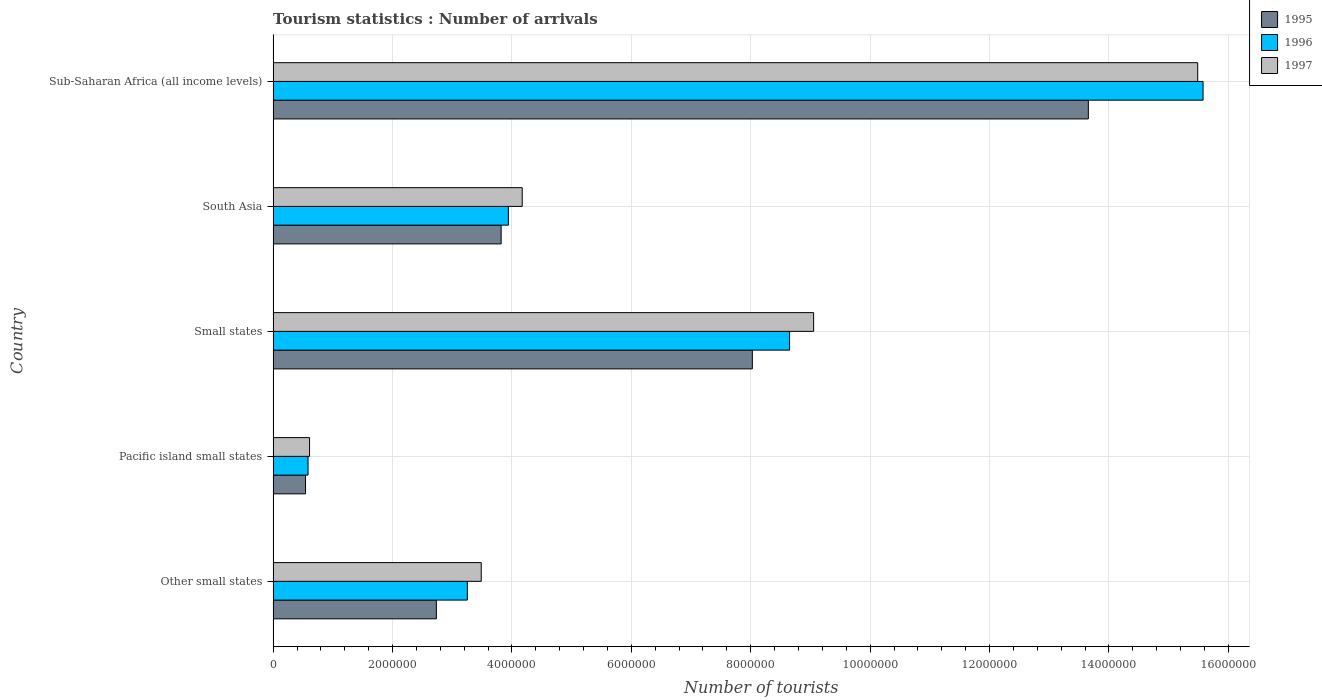How many different coloured bars are there?
Keep it short and to the point. 3. Are the number of bars per tick equal to the number of legend labels?
Your response must be concise. Yes. Are the number of bars on each tick of the Y-axis equal?
Give a very brief answer. Yes. What is the label of the 5th group of bars from the top?
Your response must be concise. Other small states. In how many cases, is the number of bars for a given country not equal to the number of legend labels?
Offer a very short reply. 0. What is the number of tourist arrivals in 1996 in South Asia?
Your response must be concise. 3.94e+06. Across all countries, what is the maximum number of tourist arrivals in 1997?
Provide a succinct answer. 1.55e+07. Across all countries, what is the minimum number of tourist arrivals in 1995?
Offer a very short reply. 5.43e+05. In which country was the number of tourist arrivals in 1997 maximum?
Your answer should be very brief. Sub-Saharan Africa (all income levels). In which country was the number of tourist arrivals in 1997 minimum?
Keep it short and to the point. Pacific island small states. What is the total number of tourist arrivals in 1997 in the graph?
Offer a very short reply. 3.28e+07. What is the difference between the number of tourist arrivals in 1995 in South Asia and that in Sub-Saharan Africa (all income levels)?
Make the answer very short. -9.84e+06. What is the difference between the number of tourist arrivals in 1995 in South Asia and the number of tourist arrivals in 1997 in Other small states?
Your answer should be very brief. 3.34e+05. What is the average number of tourist arrivals in 1997 per country?
Give a very brief answer. 6.56e+06. What is the difference between the number of tourist arrivals in 1997 and number of tourist arrivals in 1995 in Sub-Saharan Africa (all income levels)?
Your answer should be compact. 1.83e+06. In how many countries, is the number of tourist arrivals in 1997 greater than 10400000 ?
Make the answer very short. 1. What is the ratio of the number of tourist arrivals in 1997 in Other small states to that in South Asia?
Make the answer very short. 0.84. What is the difference between the highest and the second highest number of tourist arrivals in 1995?
Keep it short and to the point. 5.63e+06. What is the difference between the highest and the lowest number of tourist arrivals in 1996?
Give a very brief answer. 1.50e+07. In how many countries, is the number of tourist arrivals in 1996 greater than the average number of tourist arrivals in 1996 taken over all countries?
Make the answer very short. 2. Is the sum of the number of tourist arrivals in 1997 in Other small states and South Asia greater than the maximum number of tourist arrivals in 1996 across all countries?
Offer a very short reply. No. What does the 3rd bar from the bottom in Small states represents?
Ensure brevity in your answer.  1997. Are all the bars in the graph horizontal?
Make the answer very short. Yes. Does the graph contain grids?
Your answer should be very brief. Yes. Where does the legend appear in the graph?
Offer a very short reply. Top right. How many legend labels are there?
Keep it short and to the point. 3. What is the title of the graph?
Provide a short and direct response. Tourism statistics : Number of arrivals. What is the label or title of the X-axis?
Provide a succinct answer. Number of tourists. What is the label or title of the Y-axis?
Make the answer very short. Country. What is the Number of tourists of 1995 in Other small states?
Keep it short and to the point. 2.73e+06. What is the Number of tourists in 1996 in Other small states?
Provide a short and direct response. 3.25e+06. What is the Number of tourists in 1997 in Other small states?
Offer a terse response. 3.49e+06. What is the Number of tourists of 1995 in Pacific island small states?
Your response must be concise. 5.43e+05. What is the Number of tourists of 1996 in Pacific island small states?
Make the answer very short. 5.85e+05. What is the Number of tourists of 1997 in Pacific island small states?
Offer a very short reply. 6.10e+05. What is the Number of tourists in 1995 in Small states?
Provide a short and direct response. 8.03e+06. What is the Number of tourists in 1996 in Small states?
Offer a terse response. 8.65e+06. What is the Number of tourists of 1997 in Small states?
Your answer should be compact. 9.05e+06. What is the Number of tourists of 1995 in South Asia?
Provide a succinct answer. 3.82e+06. What is the Number of tourists of 1996 in South Asia?
Your response must be concise. 3.94e+06. What is the Number of tourists in 1997 in South Asia?
Provide a succinct answer. 4.17e+06. What is the Number of tourists in 1995 in Sub-Saharan Africa (all income levels)?
Offer a terse response. 1.37e+07. What is the Number of tourists in 1996 in Sub-Saharan Africa (all income levels)?
Ensure brevity in your answer.  1.56e+07. What is the Number of tourists in 1997 in Sub-Saharan Africa (all income levels)?
Make the answer very short. 1.55e+07. Across all countries, what is the maximum Number of tourists of 1995?
Your response must be concise. 1.37e+07. Across all countries, what is the maximum Number of tourists in 1996?
Your answer should be very brief. 1.56e+07. Across all countries, what is the maximum Number of tourists of 1997?
Your answer should be compact. 1.55e+07. Across all countries, what is the minimum Number of tourists in 1995?
Provide a short and direct response. 5.43e+05. Across all countries, what is the minimum Number of tourists in 1996?
Provide a short and direct response. 5.85e+05. Across all countries, what is the minimum Number of tourists of 1997?
Give a very brief answer. 6.10e+05. What is the total Number of tourists of 1995 in the graph?
Provide a short and direct response. 2.88e+07. What is the total Number of tourists in 1996 in the graph?
Your answer should be very brief. 3.20e+07. What is the total Number of tourists in 1997 in the graph?
Make the answer very short. 3.28e+07. What is the difference between the Number of tourists of 1995 in Other small states and that in Pacific island small states?
Ensure brevity in your answer.  2.19e+06. What is the difference between the Number of tourists of 1996 in Other small states and that in Pacific island small states?
Your answer should be very brief. 2.67e+06. What is the difference between the Number of tourists of 1997 in Other small states and that in Pacific island small states?
Make the answer very short. 2.88e+06. What is the difference between the Number of tourists of 1995 in Other small states and that in Small states?
Ensure brevity in your answer.  -5.29e+06. What is the difference between the Number of tourists of 1996 in Other small states and that in Small states?
Offer a terse response. -5.40e+06. What is the difference between the Number of tourists in 1997 in Other small states and that in Small states?
Provide a succinct answer. -5.57e+06. What is the difference between the Number of tourists of 1995 in Other small states and that in South Asia?
Offer a very short reply. -1.08e+06. What is the difference between the Number of tourists of 1996 in Other small states and that in South Asia?
Give a very brief answer. -6.87e+05. What is the difference between the Number of tourists in 1997 in Other small states and that in South Asia?
Make the answer very short. -6.87e+05. What is the difference between the Number of tourists of 1995 in Other small states and that in Sub-Saharan Africa (all income levels)?
Your answer should be very brief. -1.09e+07. What is the difference between the Number of tourists of 1996 in Other small states and that in Sub-Saharan Africa (all income levels)?
Ensure brevity in your answer.  -1.23e+07. What is the difference between the Number of tourists of 1997 in Other small states and that in Sub-Saharan Africa (all income levels)?
Provide a succinct answer. -1.20e+07. What is the difference between the Number of tourists of 1995 in Pacific island small states and that in Small states?
Offer a very short reply. -7.48e+06. What is the difference between the Number of tourists in 1996 in Pacific island small states and that in Small states?
Keep it short and to the point. -8.07e+06. What is the difference between the Number of tourists of 1997 in Pacific island small states and that in Small states?
Offer a terse response. -8.44e+06. What is the difference between the Number of tourists in 1995 in Pacific island small states and that in South Asia?
Your answer should be very brief. -3.28e+06. What is the difference between the Number of tourists in 1996 in Pacific island small states and that in South Asia?
Offer a very short reply. -3.36e+06. What is the difference between the Number of tourists in 1997 in Pacific island small states and that in South Asia?
Your answer should be compact. -3.56e+06. What is the difference between the Number of tourists in 1995 in Pacific island small states and that in Sub-Saharan Africa (all income levels)?
Your answer should be compact. -1.31e+07. What is the difference between the Number of tourists of 1996 in Pacific island small states and that in Sub-Saharan Africa (all income levels)?
Offer a very short reply. -1.50e+07. What is the difference between the Number of tourists of 1997 in Pacific island small states and that in Sub-Saharan Africa (all income levels)?
Give a very brief answer. -1.49e+07. What is the difference between the Number of tourists of 1995 in Small states and that in South Asia?
Offer a very short reply. 4.21e+06. What is the difference between the Number of tourists of 1996 in Small states and that in South Asia?
Offer a very short reply. 4.71e+06. What is the difference between the Number of tourists in 1997 in Small states and that in South Asia?
Offer a very short reply. 4.88e+06. What is the difference between the Number of tourists of 1995 in Small states and that in Sub-Saharan Africa (all income levels)?
Provide a succinct answer. -5.63e+06. What is the difference between the Number of tourists in 1996 in Small states and that in Sub-Saharan Africa (all income levels)?
Your answer should be compact. -6.93e+06. What is the difference between the Number of tourists of 1997 in Small states and that in Sub-Saharan Africa (all income levels)?
Your answer should be very brief. -6.43e+06. What is the difference between the Number of tourists in 1995 in South Asia and that in Sub-Saharan Africa (all income levels)?
Keep it short and to the point. -9.84e+06. What is the difference between the Number of tourists of 1996 in South Asia and that in Sub-Saharan Africa (all income levels)?
Ensure brevity in your answer.  -1.16e+07. What is the difference between the Number of tourists in 1997 in South Asia and that in Sub-Saharan Africa (all income levels)?
Provide a succinct answer. -1.13e+07. What is the difference between the Number of tourists in 1995 in Other small states and the Number of tourists in 1996 in Pacific island small states?
Provide a succinct answer. 2.15e+06. What is the difference between the Number of tourists of 1995 in Other small states and the Number of tourists of 1997 in Pacific island small states?
Your answer should be very brief. 2.12e+06. What is the difference between the Number of tourists of 1996 in Other small states and the Number of tourists of 1997 in Pacific island small states?
Provide a succinct answer. 2.64e+06. What is the difference between the Number of tourists of 1995 in Other small states and the Number of tourists of 1996 in Small states?
Give a very brief answer. -5.92e+06. What is the difference between the Number of tourists of 1995 in Other small states and the Number of tourists of 1997 in Small states?
Give a very brief answer. -6.32e+06. What is the difference between the Number of tourists in 1996 in Other small states and the Number of tourists in 1997 in Small states?
Provide a succinct answer. -5.80e+06. What is the difference between the Number of tourists of 1995 in Other small states and the Number of tourists of 1996 in South Asia?
Ensure brevity in your answer.  -1.21e+06. What is the difference between the Number of tourists of 1995 in Other small states and the Number of tourists of 1997 in South Asia?
Offer a terse response. -1.44e+06. What is the difference between the Number of tourists of 1996 in Other small states and the Number of tourists of 1997 in South Asia?
Provide a short and direct response. -9.19e+05. What is the difference between the Number of tourists in 1995 in Other small states and the Number of tourists in 1996 in Sub-Saharan Africa (all income levels)?
Your answer should be very brief. -1.28e+07. What is the difference between the Number of tourists in 1995 in Other small states and the Number of tourists in 1997 in Sub-Saharan Africa (all income levels)?
Make the answer very short. -1.28e+07. What is the difference between the Number of tourists of 1996 in Other small states and the Number of tourists of 1997 in Sub-Saharan Africa (all income levels)?
Give a very brief answer. -1.22e+07. What is the difference between the Number of tourists of 1995 in Pacific island small states and the Number of tourists of 1996 in Small states?
Provide a short and direct response. -8.11e+06. What is the difference between the Number of tourists of 1995 in Pacific island small states and the Number of tourists of 1997 in Small states?
Keep it short and to the point. -8.51e+06. What is the difference between the Number of tourists of 1996 in Pacific island small states and the Number of tourists of 1997 in Small states?
Offer a terse response. -8.47e+06. What is the difference between the Number of tourists in 1995 in Pacific island small states and the Number of tourists in 1996 in South Asia?
Your answer should be very brief. -3.40e+06. What is the difference between the Number of tourists in 1995 in Pacific island small states and the Number of tourists in 1997 in South Asia?
Provide a short and direct response. -3.63e+06. What is the difference between the Number of tourists in 1996 in Pacific island small states and the Number of tourists in 1997 in South Asia?
Ensure brevity in your answer.  -3.59e+06. What is the difference between the Number of tourists in 1995 in Pacific island small states and the Number of tourists in 1996 in Sub-Saharan Africa (all income levels)?
Your answer should be compact. -1.50e+07. What is the difference between the Number of tourists in 1995 in Pacific island small states and the Number of tourists in 1997 in Sub-Saharan Africa (all income levels)?
Your answer should be very brief. -1.49e+07. What is the difference between the Number of tourists in 1996 in Pacific island small states and the Number of tourists in 1997 in Sub-Saharan Africa (all income levels)?
Give a very brief answer. -1.49e+07. What is the difference between the Number of tourists in 1995 in Small states and the Number of tourists in 1996 in South Asia?
Make the answer very short. 4.09e+06. What is the difference between the Number of tourists in 1995 in Small states and the Number of tourists in 1997 in South Asia?
Provide a succinct answer. 3.85e+06. What is the difference between the Number of tourists in 1996 in Small states and the Number of tourists in 1997 in South Asia?
Offer a very short reply. 4.48e+06. What is the difference between the Number of tourists in 1995 in Small states and the Number of tourists in 1996 in Sub-Saharan Africa (all income levels)?
Give a very brief answer. -7.55e+06. What is the difference between the Number of tourists of 1995 in Small states and the Number of tourists of 1997 in Sub-Saharan Africa (all income levels)?
Make the answer very short. -7.46e+06. What is the difference between the Number of tourists of 1996 in Small states and the Number of tourists of 1997 in Sub-Saharan Africa (all income levels)?
Ensure brevity in your answer.  -6.84e+06. What is the difference between the Number of tourists in 1995 in South Asia and the Number of tourists in 1996 in Sub-Saharan Africa (all income levels)?
Offer a terse response. -1.18e+07. What is the difference between the Number of tourists in 1995 in South Asia and the Number of tourists in 1997 in Sub-Saharan Africa (all income levels)?
Keep it short and to the point. -1.17e+07. What is the difference between the Number of tourists of 1996 in South Asia and the Number of tourists of 1997 in Sub-Saharan Africa (all income levels)?
Offer a very short reply. -1.15e+07. What is the average Number of tourists in 1995 per country?
Offer a terse response. 5.76e+06. What is the average Number of tourists of 1996 per country?
Make the answer very short. 6.40e+06. What is the average Number of tourists of 1997 per country?
Provide a succinct answer. 6.56e+06. What is the difference between the Number of tourists of 1995 and Number of tourists of 1996 in Other small states?
Ensure brevity in your answer.  -5.19e+05. What is the difference between the Number of tourists in 1995 and Number of tourists in 1997 in Other small states?
Provide a succinct answer. -7.51e+05. What is the difference between the Number of tourists in 1996 and Number of tourists in 1997 in Other small states?
Make the answer very short. -2.32e+05. What is the difference between the Number of tourists in 1995 and Number of tourists in 1996 in Pacific island small states?
Give a very brief answer. -4.20e+04. What is the difference between the Number of tourists in 1995 and Number of tourists in 1997 in Pacific island small states?
Offer a very short reply. -6.75e+04. What is the difference between the Number of tourists in 1996 and Number of tourists in 1997 in Pacific island small states?
Offer a terse response. -2.55e+04. What is the difference between the Number of tourists in 1995 and Number of tourists in 1996 in Small states?
Offer a very short reply. -6.24e+05. What is the difference between the Number of tourists of 1995 and Number of tourists of 1997 in Small states?
Ensure brevity in your answer.  -1.03e+06. What is the difference between the Number of tourists of 1996 and Number of tourists of 1997 in Small states?
Ensure brevity in your answer.  -4.03e+05. What is the difference between the Number of tourists in 1995 and Number of tourists in 1996 in South Asia?
Offer a very short reply. -1.21e+05. What is the difference between the Number of tourists of 1995 and Number of tourists of 1997 in South Asia?
Provide a short and direct response. -3.53e+05. What is the difference between the Number of tourists of 1996 and Number of tourists of 1997 in South Asia?
Provide a succinct answer. -2.32e+05. What is the difference between the Number of tourists of 1995 and Number of tourists of 1996 in Sub-Saharan Africa (all income levels)?
Provide a succinct answer. -1.92e+06. What is the difference between the Number of tourists in 1995 and Number of tourists in 1997 in Sub-Saharan Africa (all income levels)?
Provide a succinct answer. -1.83e+06. What is the difference between the Number of tourists in 1996 and Number of tourists in 1997 in Sub-Saharan Africa (all income levels)?
Give a very brief answer. 8.97e+04. What is the ratio of the Number of tourists of 1995 in Other small states to that in Pacific island small states?
Give a very brief answer. 5.04. What is the ratio of the Number of tourists in 1996 in Other small states to that in Pacific island small states?
Ensure brevity in your answer.  5.56. What is the ratio of the Number of tourists of 1997 in Other small states to that in Pacific island small states?
Provide a succinct answer. 5.71. What is the ratio of the Number of tourists of 1995 in Other small states to that in Small states?
Your answer should be compact. 0.34. What is the ratio of the Number of tourists in 1996 in Other small states to that in Small states?
Provide a succinct answer. 0.38. What is the ratio of the Number of tourists in 1997 in Other small states to that in Small states?
Your answer should be very brief. 0.39. What is the ratio of the Number of tourists of 1995 in Other small states to that in South Asia?
Give a very brief answer. 0.72. What is the ratio of the Number of tourists of 1996 in Other small states to that in South Asia?
Make the answer very short. 0.83. What is the ratio of the Number of tourists in 1997 in Other small states to that in South Asia?
Offer a very short reply. 0.84. What is the ratio of the Number of tourists of 1995 in Other small states to that in Sub-Saharan Africa (all income levels)?
Your answer should be compact. 0.2. What is the ratio of the Number of tourists of 1996 in Other small states to that in Sub-Saharan Africa (all income levels)?
Your answer should be compact. 0.21. What is the ratio of the Number of tourists in 1997 in Other small states to that in Sub-Saharan Africa (all income levels)?
Give a very brief answer. 0.23. What is the ratio of the Number of tourists of 1995 in Pacific island small states to that in Small states?
Your response must be concise. 0.07. What is the ratio of the Number of tourists of 1996 in Pacific island small states to that in Small states?
Your answer should be very brief. 0.07. What is the ratio of the Number of tourists of 1997 in Pacific island small states to that in Small states?
Your response must be concise. 0.07. What is the ratio of the Number of tourists in 1995 in Pacific island small states to that in South Asia?
Your answer should be compact. 0.14. What is the ratio of the Number of tourists in 1996 in Pacific island small states to that in South Asia?
Your response must be concise. 0.15. What is the ratio of the Number of tourists in 1997 in Pacific island small states to that in South Asia?
Offer a very short reply. 0.15. What is the ratio of the Number of tourists in 1995 in Pacific island small states to that in Sub-Saharan Africa (all income levels)?
Your response must be concise. 0.04. What is the ratio of the Number of tourists of 1996 in Pacific island small states to that in Sub-Saharan Africa (all income levels)?
Your response must be concise. 0.04. What is the ratio of the Number of tourists in 1997 in Pacific island small states to that in Sub-Saharan Africa (all income levels)?
Ensure brevity in your answer.  0.04. What is the ratio of the Number of tourists in 1995 in Small states to that in South Asia?
Your answer should be very brief. 2.1. What is the ratio of the Number of tourists in 1996 in Small states to that in South Asia?
Offer a very short reply. 2.2. What is the ratio of the Number of tourists of 1997 in Small states to that in South Asia?
Your answer should be compact. 2.17. What is the ratio of the Number of tourists of 1995 in Small states to that in Sub-Saharan Africa (all income levels)?
Provide a succinct answer. 0.59. What is the ratio of the Number of tourists in 1996 in Small states to that in Sub-Saharan Africa (all income levels)?
Make the answer very short. 0.56. What is the ratio of the Number of tourists in 1997 in Small states to that in Sub-Saharan Africa (all income levels)?
Your answer should be compact. 0.58. What is the ratio of the Number of tourists in 1995 in South Asia to that in Sub-Saharan Africa (all income levels)?
Your answer should be compact. 0.28. What is the ratio of the Number of tourists in 1996 in South Asia to that in Sub-Saharan Africa (all income levels)?
Offer a terse response. 0.25. What is the ratio of the Number of tourists in 1997 in South Asia to that in Sub-Saharan Africa (all income levels)?
Ensure brevity in your answer.  0.27. What is the difference between the highest and the second highest Number of tourists in 1995?
Make the answer very short. 5.63e+06. What is the difference between the highest and the second highest Number of tourists of 1996?
Provide a succinct answer. 6.93e+06. What is the difference between the highest and the second highest Number of tourists in 1997?
Provide a short and direct response. 6.43e+06. What is the difference between the highest and the lowest Number of tourists in 1995?
Provide a short and direct response. 1.31e+07. What is the difference between the highest and the lowest Number of tourists in 1996?
Provide a short and direct response. 1.50e+07. What is the difference between the highest and the lowest Number of tourists of 1997?
Your response must be concise. 1.49e+07. 